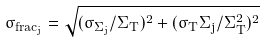<formula> <loc_0><loc_0><loc_500><loc_500>\sigma _ { f r a c _ { j } } = \sqrt { ( \sigma _ { \Sigma _ { j } } / \Sigma _ { T } ) ^ { 2 } + ( \sigma _ { T } \Sigma _ { j } / \Sigma _ { T } ^ { 2 } ) ^ { 2 } }</formula> 